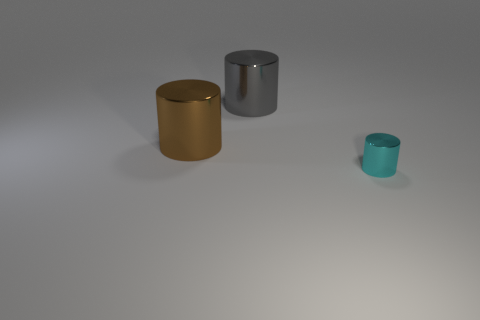Subtract all big metal cylinders. How many cylinders are left? 1 Add 3 big green metallic objects. How many objects exist? 6 Subtract all purple cylinders. Subtract all purple blocks. How many cylinders are left? 3 Subtract all tiny blue objects. Subtract all big brown cylinders. How many objects are left? 2 Add 1 brown metal things. How many brown metal things are left? 2 Add 3 matte spheres. How many matte spheres exist? 3 Subtract 1 cyan cylinders. How many objects are left? 2 